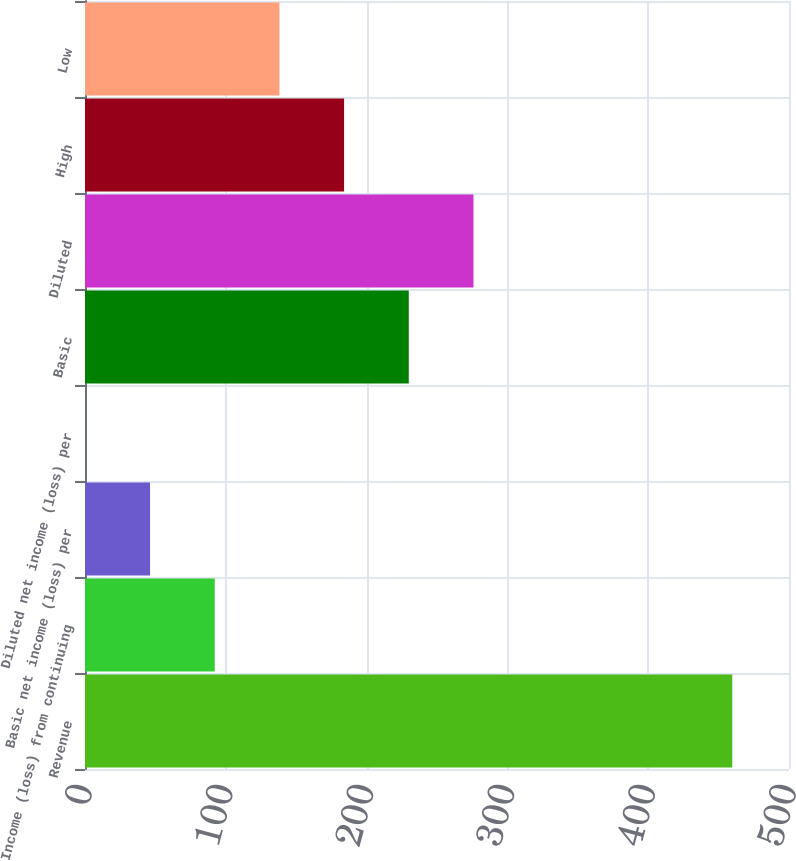Convert chart. <chart><loc_0><loc_0><loc_500><loc_500><bar_chart><fcel>Revenue<fcel>Income (loss) from continuing<fcel>Basic net income (loss) per<fcel>Diluted net income (loss) per<fcel>Basic<fcel>Diluted<fcel>High<fcel>Low<nl><fcel>459.7<fcel>92.14<fcel>46.2<fcel>0.26<fcel>229.96<fcel>275.9<fcel>184.02<fcel>138.08<nl></chart> 